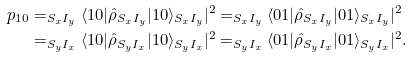Convert formula to latex. <formula><loc_0><loc_0><loc_500><loc_500>p _ { 1 0 } & = _ { S _ { x } I _ { y } } \langle 1 0 | \hat { \rho } _ { S _ { x } I _ { y } } | 1 0 \rangle _ { S _ { x } I _ { y } } | ^ { 2 } = _ { S _ { x } I _ { y } } \langle 0 1 | \hat { \rho } _ { S _ { x } I _ { y } } | 0 1 \rangle _ { S _ { x } I _ { y } } | ^ { 2 } \\ & = _ { S _ { y } I _ { x } } \langle 1 0 | \hat { \rho } _ { S _ { y } I _ { x } } | 1 0 \rangle _ { S _ { y } I _ { x } } | ^ { 2 } = _ { S _ { y } I _ { x } } \langle 0 1 | \hat { \rho } _ { S _ { y } I _ { x } } | 0 1 \rangle _ { S _ { y } I _ { x } } | ^ { 2 } .</formula> 